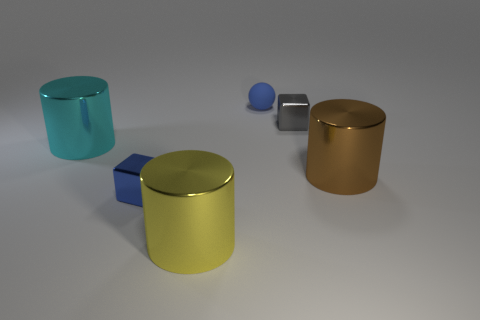There is a cyan object that is the same shape as the brown object; what is its size?
Keep it short and to the point. Large. Are there any other things that are the same material as the small blue cube?
Make the answer very short. Yes. There is a tiny block on the right side of the blue rubber sphere that is left of the gray metal block; is there a tiny gray shiny thing that is to the left of it?
Your answer should be compact. No. There is a small block that is to the right of the large yellow metal cylinder; what is its material?
Your response must be concise. Metal. How many small objects are either yellow metal cylinders or brown shiny cylinders?
Make the answer very short. 0. There is a cylinder in front of the blue cube; is it the same size as the small rubber object?
Offer a terse response. No. What number of other things are there of the same color as the ball?
Give a very brief answer. 1. What is the cyan object made of?
Make the answer very short. Metal. What is the material of the thing that is both behind the brown cylinder and in front of the gray object?
Your answer should be compact. Metal. What number of things are either cylinders on the right side of the tiny gray block or green shiny balls?
Give a very brief answer. 1. 